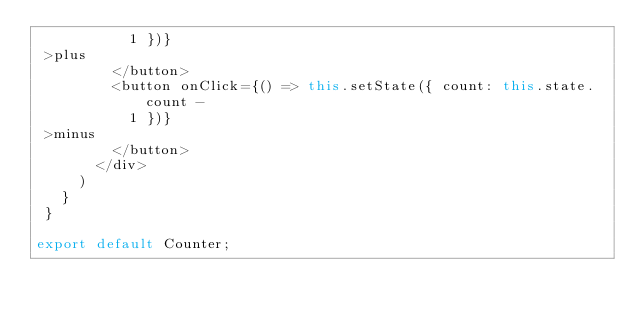Convert code to text. <code><loc_0><loc_0><loc_500><loc_500><_JavaScript_>           1 })}
 >plus
         </button>
         <button onClick={() => this.setState({ count: this.state.count -
           1 })}
 >minus
         </button>
       </div>
     )
   }
 }

export default Counter;
</code> 